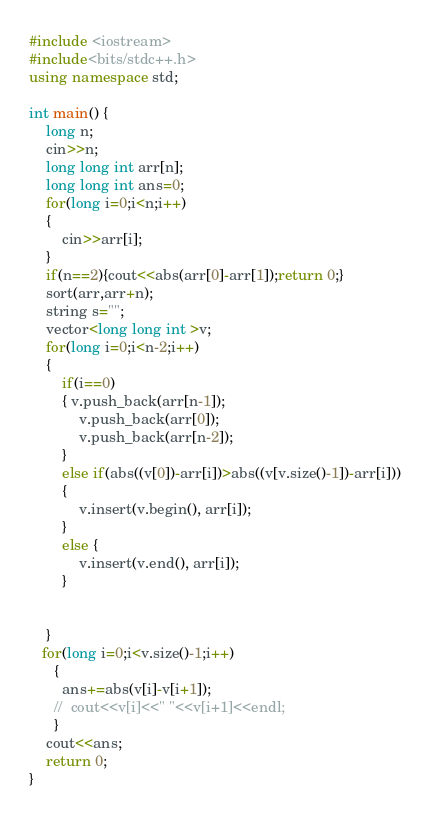Convert code to text. <code><loc_0><loc_0><loc_500><loc_500><_C++_>#include <iostream>
#include<bits/stdc++.h>
using namespace std;
 
int main() {
	long n;
	cin>>n;
	long long int arr[n];
	long long int ans=0;
	for(long i=0;i<n;i++)
	{
		cin>>arr[i];
	}
	if(n==2){cout<<abs(arr[0]-arr[1]);return 0;}
	sort(arr,arr+n);
    string s="";
    vector<long long int >v;
    for(long i=0;i<n-2;i++)
    {
    	if(i==0)
    	{ v.push_back(arr[n-1]);
    		v.push_back(arr[0]);
    		v.push_back(arr[n-2]);
    	}
    	else if(abs((v[0])-arr[i])>abs((v[v.size()-1])-arr[i]))
    	{
    		v.insert(v.begin(), arr[i]);
    	}
    	else {
    		v.insert(v.end(), arr[i]);
    	}
    		
    	
    }
   for(long i=0;i<v.size()-1;i++)
      {
      	ans+=abs(v[i]-v[i+1]);
      //	cout<<v[i]<<" "<<v[i+1]<<endl;
      }
    cout<<ans;
	return 0;
}</code> 